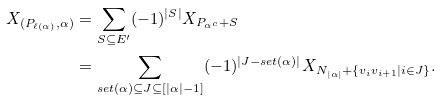Convert formula to latex. <formula><loc_0><loc_0><loc_500><loc_500>X _ { ( P _ { \ell ( \alpha ) } , \alpha ) } & = \sum _ { S \subseteq E ^ { \prime } } ( - 1 ) ^ { | S | } X _ { P _ { \alpha ^ { c } } + S } \\ & = \sum _ { s e t ( \alpha ) \subseteq J \subseteq [ | \alpha | - 1 ] } ( - 1 ) ^ { | J - s e t ( \alpha ) | } X _ { N _ { | \alpha | } + \{ v _ { i } v _ { i + 1 } | i \in J \} } .</formula> 